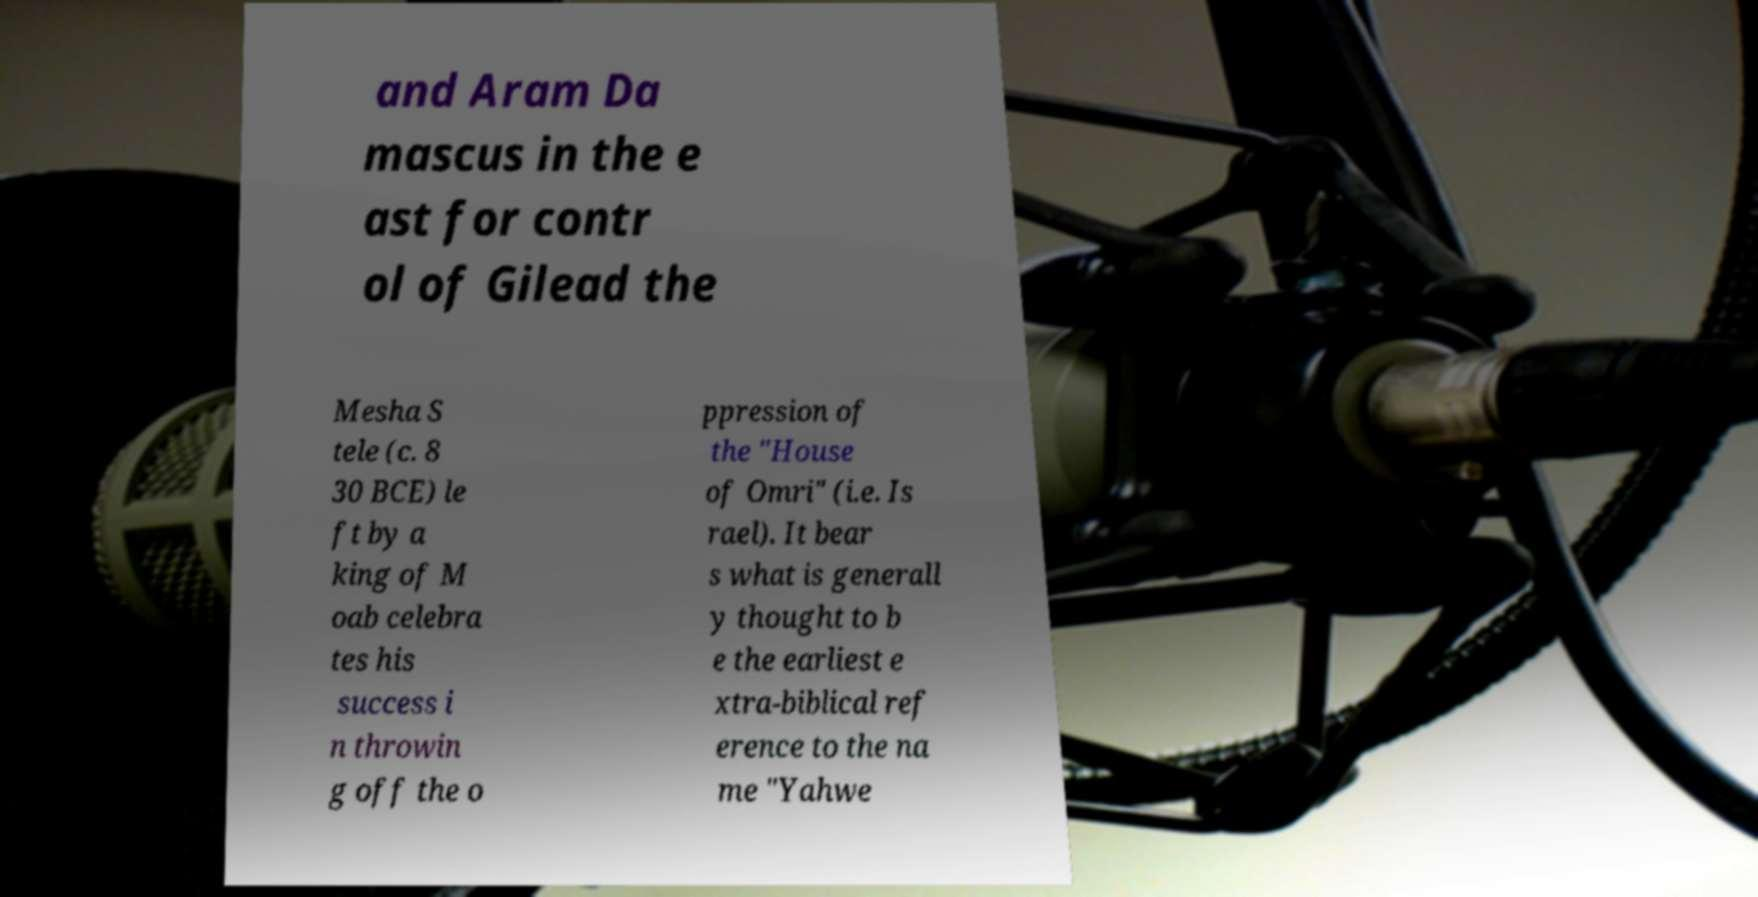Could you assist in decoding the text presented in this image and type it out clearly? and Aram Da mascus in the e ast for contr ol of Gilead the Mesha S tele (c. 8 30 BCE) le ft by a king of M oab celebra tes his success i n throwin g off the o ppression of the "House of Omri" (i.e. Is rael). It bear s what is generall y thought to b e the earliest e xtra-biblical ref erence to the na me "Yahwe 